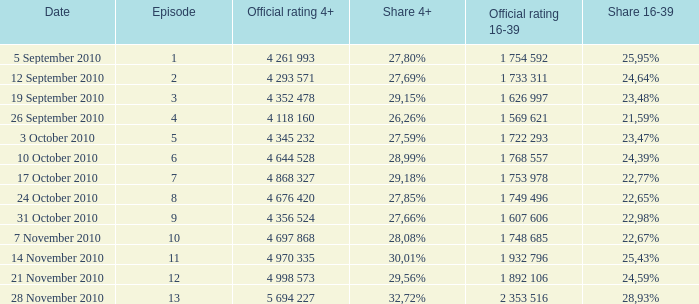What is the official score 16-39 for the episode with a 16-39 share of 2 1 753 978. Could you parse the entire table? {'header': ['Date', 'Episode', 'Official rating 4+', 'Share 4+', 'Official rating 16-39', 'Share 16-39'], 'rows': [['5 September 2010', '1', '4 261 993', '27,80%', '1 754 592', '25,95%'], ['12 September 2010', '2', '4 293 571', '27,69%', '1 733 311', '24,64%'], ['19 September 2010', '3', '4 352 478', '29,15%', '1 626 997', '23,48%'], ['26 September 2010', '4', '4 118 160', '26,26%', '1 569 621', '21,59%'], ['3 October 2010', '5', '4 345 232', '27,59%', '1 722 293', '23,47%'], ['10 October 2010', '6', '4 644 528', '28,99%', '1 768 557', '24,39%'], ['17 October 2010', '7', '4 868 327', '29,18%', '1 753 978', '22,77%'], ['24 October 2010', '8', '4 676 420', '27,85%', '1 749 496', '22,65%'], ['31 October 2010', '9', '4 356 524', '27,66%', '1 607 606', '22,98%'], ['7 November 2010', '10', '4 697 868', '28,08%', '1 748 685', '22,67%'], ['14 November 2010', '11', '4 970 335', '30,01%', '1 932 796', '25,43%'], ['21 November 2010', '12', '4 998 573', '29,56%', '1 892 106', '24,59%'], ['28 November 2010', '13', '5 694 227', '32,72%', '2 353 516', '28,93%']]} 